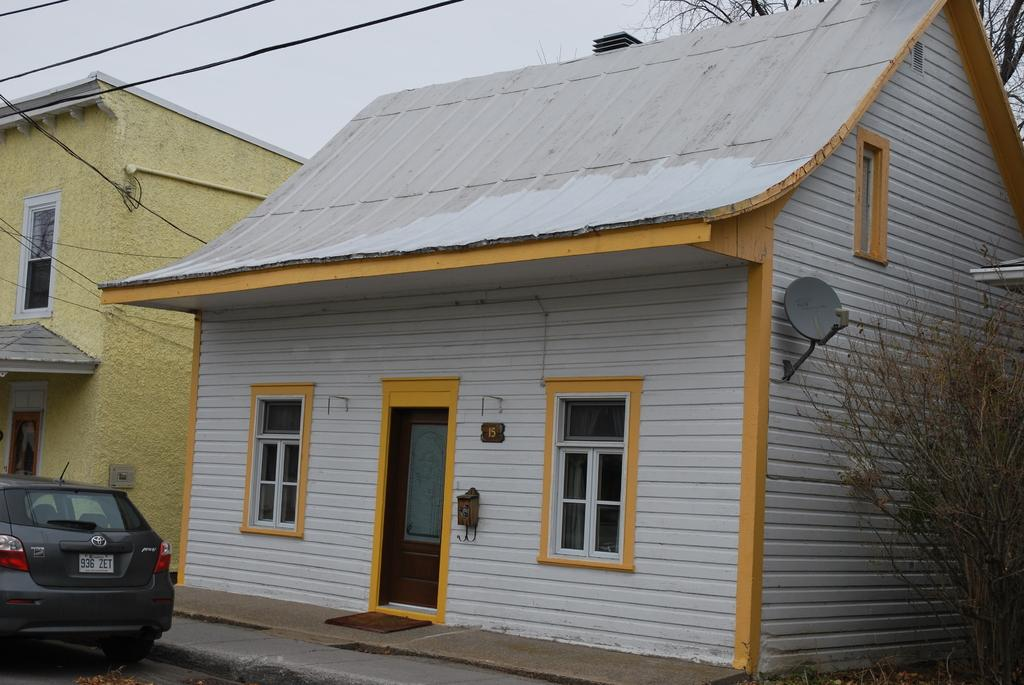What is the main subject of the image? The main subject of the image is a vehicle. Where is the vehicle located in relation to other structures? The vehicle is in front of houses. What type of natural elements can be seen in the image? There are trees visible in the image. What year is the clock in the image set to? There is no clock present in the image, so it is not possible to determine the year it is set to. 